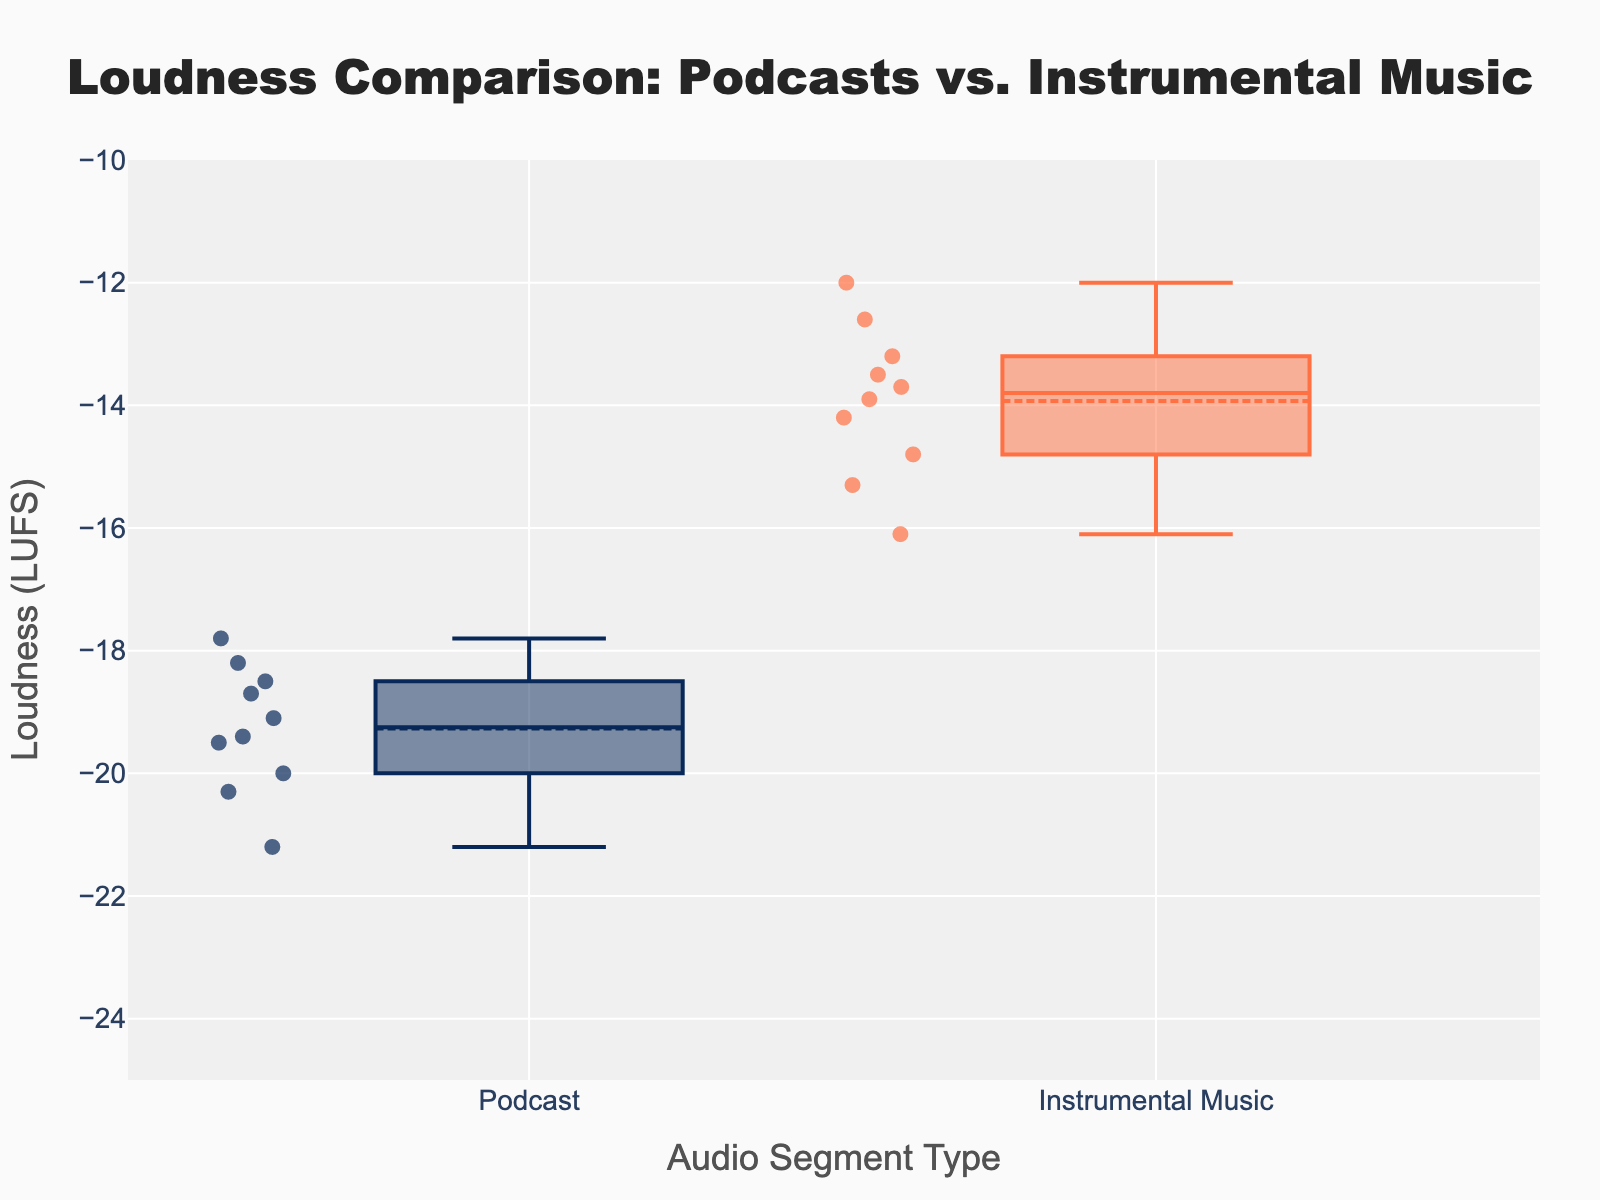What's the title of the figure? The title is prominently displayed at the top center of the figure.
Answer: Loudness Comparison: Podcasts vs. Instrumental Music What is the range of the y-axis? The range of the y-axis can be seen on the left side of the figure.
Answer: -25 to -10 LUFS How many podcast data points are there? Each point on the box plot represents a data sample and can be counted visually.
Answer: 10 Which segment type has the highest loudness? By comparing the distribution of the box plots, the segment with the highest top whisker indicates the highest loudness level.
Answer: Instrumental Music Which segment type shows more variability in loudness? The segment with a wider interquartile range (IQR) and farther spread between whiskers shows more variability.
Answer: Podcast What is the median loudness for instrumental music? Look at the central line inside the instrumental music box plot.
Answer: Around -14 LUFS Which segment seems quieter on average? Compare the means (shown as dots) of the two box plots.
Answer: Podcast What is the interquartile range (IQR) for podcasts? Calculate by subtracting the lower quartile from the upper quartile, shown in the box's corners.
Answer: Approximately 1.8 LUFS Which audio segment type has a more negative mean loudness? Compare the means (dots) in the box plots, the lower dot indicates a more negative mean.
Answer: Podcast Are there any outliers in the instrumental music data? Look for individual points that fall outside the whiskers in the instrumental music box plot.
Answer: No 